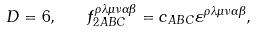<formula> <loc_0><loc_0><loc_500><loc_500>D = 6 , \quad f _ { 2 A B C } ^ { \rho \lambda \mu \nu \alpha \beta } = c _ { A B C } \varepsilon ^ { \rho \lambda \mu \nu \alpha \beta } ,</formula> 